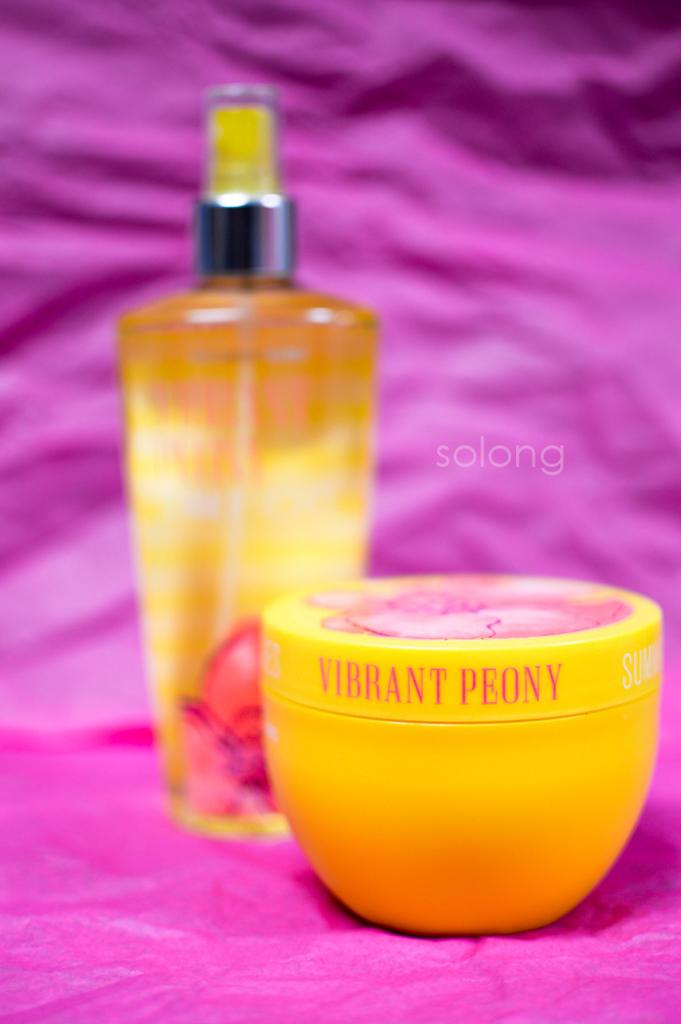<image>
Create a compact narrative representing the image presented. vibtant peony body products are sitting on a purple cloth 